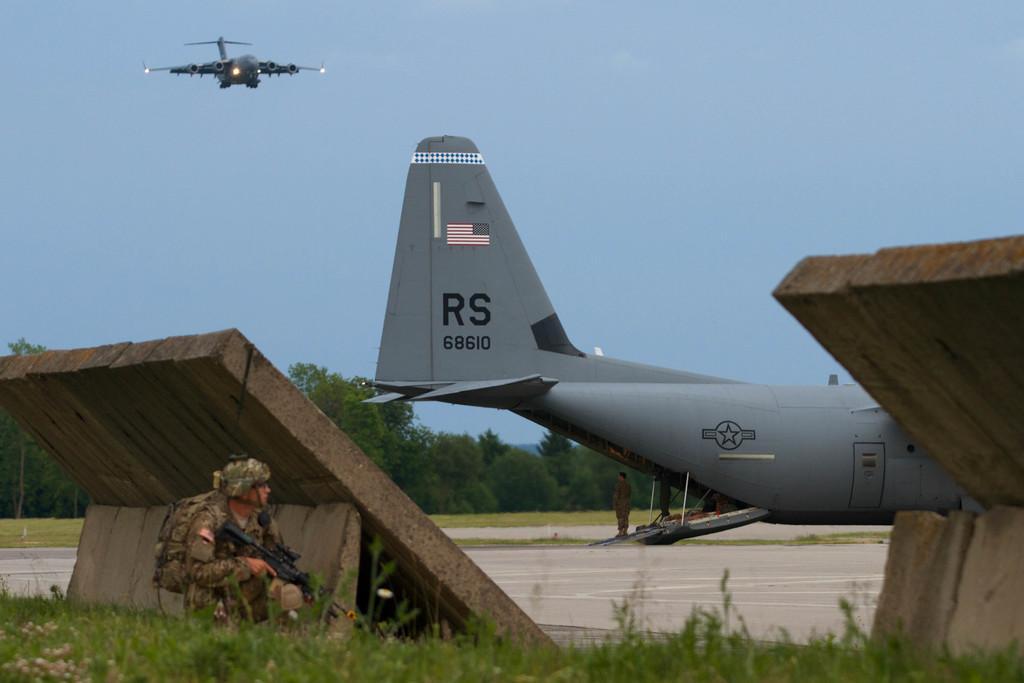Can you describe this image briefly? In this picture I can see a person with a rifle, there is grass, there are ramps, a person standing, an airplane on the runway, there are trees, and in the background there is an airplane flying in the sky. 